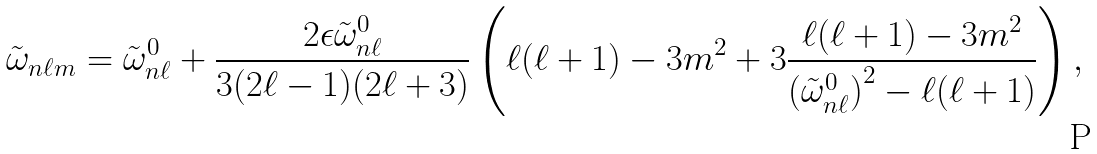Convert formula to latex. <formula><loc_0><loc_0><loc_500><loc_500>\tilde { \omega } _ { n \ell m } = \tilde { \omega } ^ { 0 } _ { n \ell } + \frac { 2 \epsilon \tilde { \omega } ^ { 0 } _ { n \ell } } { 3 ( 2 \ell - 1 ) ( 2 \ell + 3 ) } \left ( \ell ( \ell + 1 ) - 3 m ^ { 2 } + 3 \frac { \ell ( \ell + 1 ) - 3 m ^ { 2 } } { { \left ( { \tilde { \omega } } ^ { 0 } _ { n \ell } \right ) } ^ { 2 } - \ell ( \ell + 1 ) } \right ) ,</formula> 